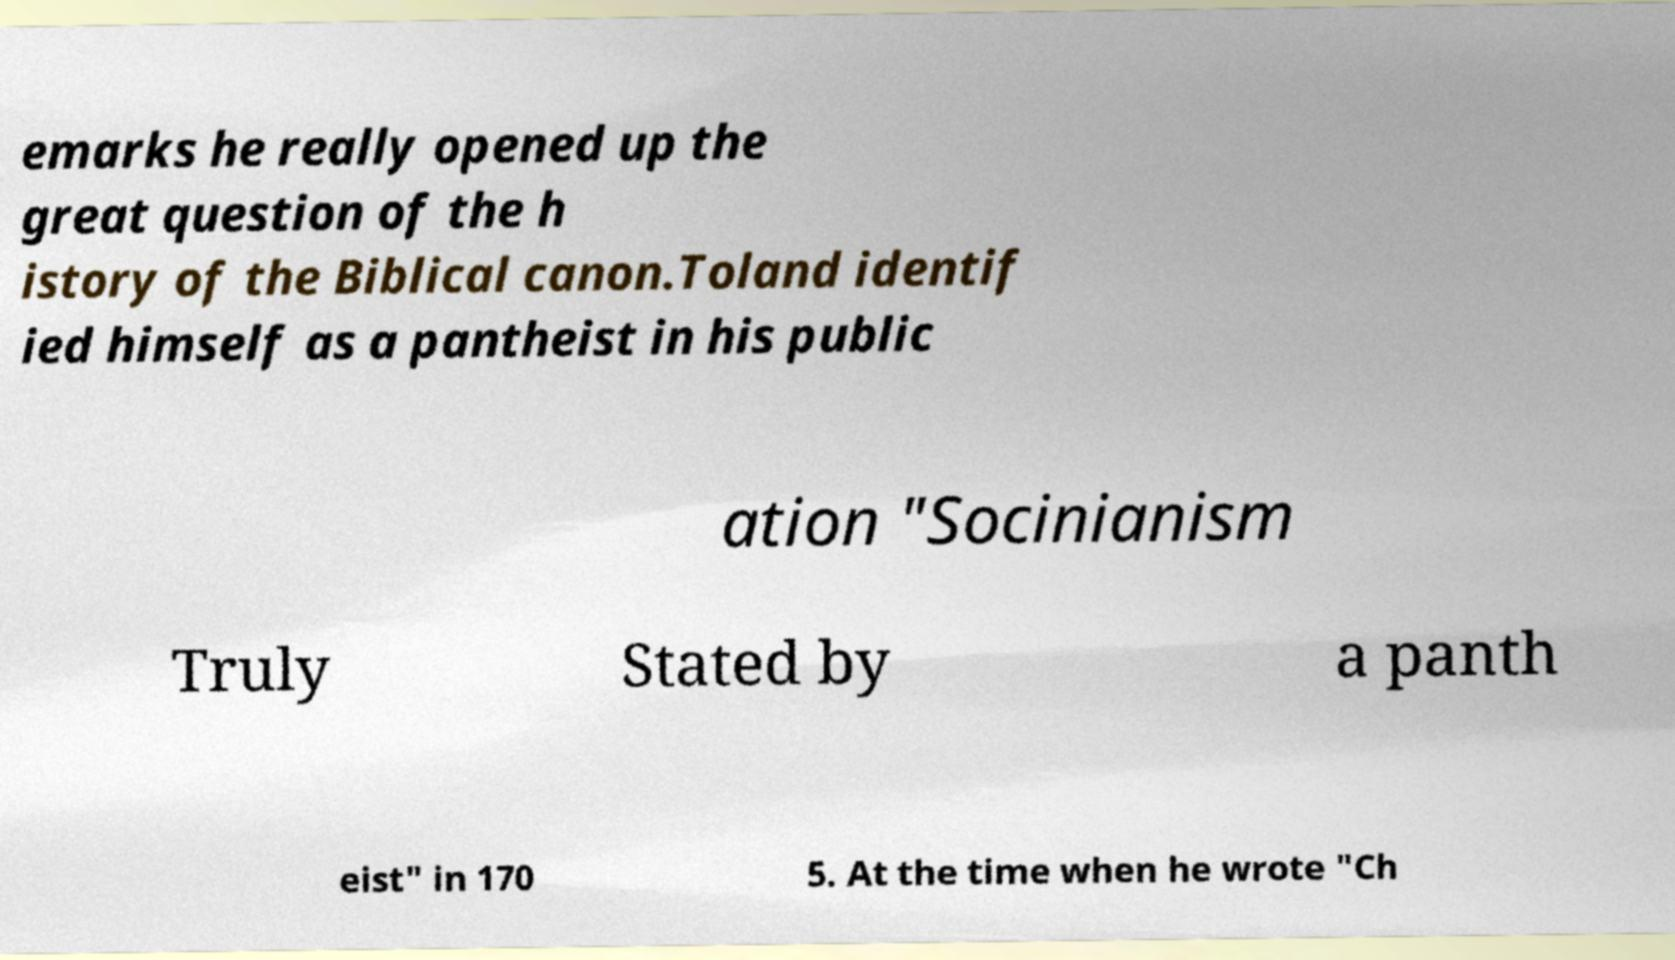Can you read and provide the text displayed in the image?This photo seems to have some interesting text. Can you extract and type it out for me? emarks he really opened up the great question of the h istory of the Biblical canon.Toland identif ied himself as a pantheist in his public ation "Socinianism Truly Stated by a panth eist" in 170 5. At the time when he wrote "Ch 